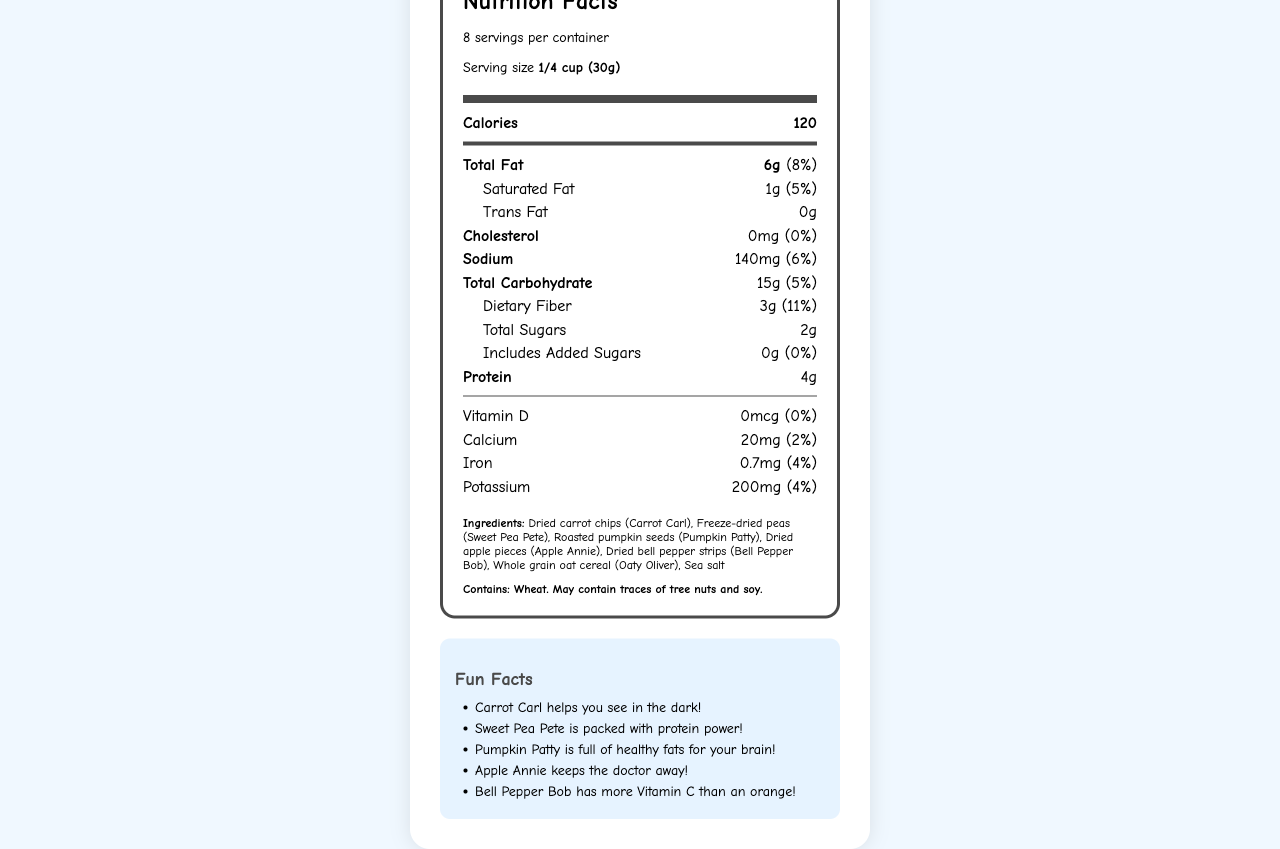What is the serving size for Rainbow Veggie Buddies Snack Mix? The serving size is mentioned at the beginning of the Nutrition Facts label as "Serving size 1/4 cup (30g)."
Answer: 1/4 cup (30g) How much total fat is there in one serving? The amount of total fat per serving is listed as "Total Fat 6g (8%)".
Answer: 6g What is the total amount of dietary fiber in the snack mix? The amount of dietary fiber per serving is noted as "Dietary Fiber 3g (11%)".
Answer: 3g What ingredients can children identify in the snack mix? The ingredients are listed in the order: "Dried carrot chips, freeze-dried peas, roasted pumpkin seeds, dried apple pieces, dried bell pepper strips, whole grain oat cereal, sea salt."
Answer: Dried carrot chips, freeze-dried peas, roasted pumpkin seeds, dried apple pieces, dried bell pepper strips, whole grain oat cereal, sea salt What fun fact is associated with Bell Pepper Bob? This fun fact is listed in the fun facts section as "Bell Pepper Bob has more Vitamin C than an orange!"
Answer: Bell Pepper Bob has more Vitamin C than an orange! How much protein does one serving of the snack mix contain? The protein amount per serving is listed as "Protein 4g."
Answer: 4g Which of the following nutrients is not present in the snack mix? (A) Trans Fat (B) Vitamin D (C) Cholesterol (D) All of the Above The document shows "Trans Fat 0g," "Vitamin D 0mcg (0%)," "Cholesterol 0mg (0%)" indicating none are present.
Answer: D How many servings are in one container of Rainbow Veggie Buddies Snack Mix? (A) 6 (B) 8 (C) 10 (D) 12 The document states "8 servings per container."
Answer: B Is there any added sugar in the Rainbow Veggie Buddies Snack Mix? The label specifies "Includes Added Sugars 0g (0%)" indicating no added sugars.
Answer: No Summary: What information does the document provide about Rainbow Veggie Buddies Snack Mix? The document contains detailed nutritional information, a list of ingredients, and fun facts about the snack mix. It also includes educational elements like identifying and counting different ingredients and learning about the nutritional benefits of colorful foods.
Answer: The document provides comprehensive nutrition facts, ingredients, allergen information, and fun facts about the Rainbow Veggie Buddies Snack Mix. It includes serving size, calorie count, and various nutrient amounts such as fats, carbohydrates, proteins, vitamins, and minerals. Additionally, it lists the ingredients with anthropomorphized vegetable characters and offers educational elements and teacher notes for engaging students in nutrition lessons. What is the exact number of calories burned by consuming one serving of this snack mix? The document only provides the number of calories in one serving, not the energy expenditure from consuming it.
Answer: Not enough information 